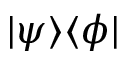Convert formula to latex. <formula><loc_0><loc_0><loc_500><loc_500>| \psi \rangle \langle \phi |</formula> 